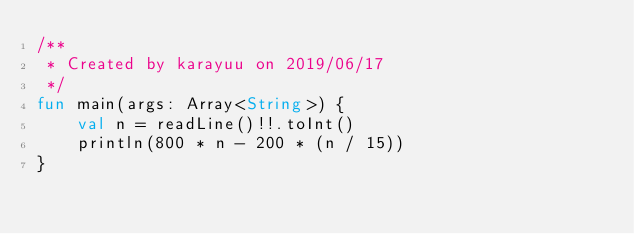Convert code to text. <code><loc_0><loc_0><loc_500><loc_500><_Kotlin_>/**
 * Created by karayuu on 2019/06/17
 */
fun main(args: Array<String>) {
    val n = readLine()!!.toInt()
    println(800 * n - 200 * (n / 15))
}
</code> 